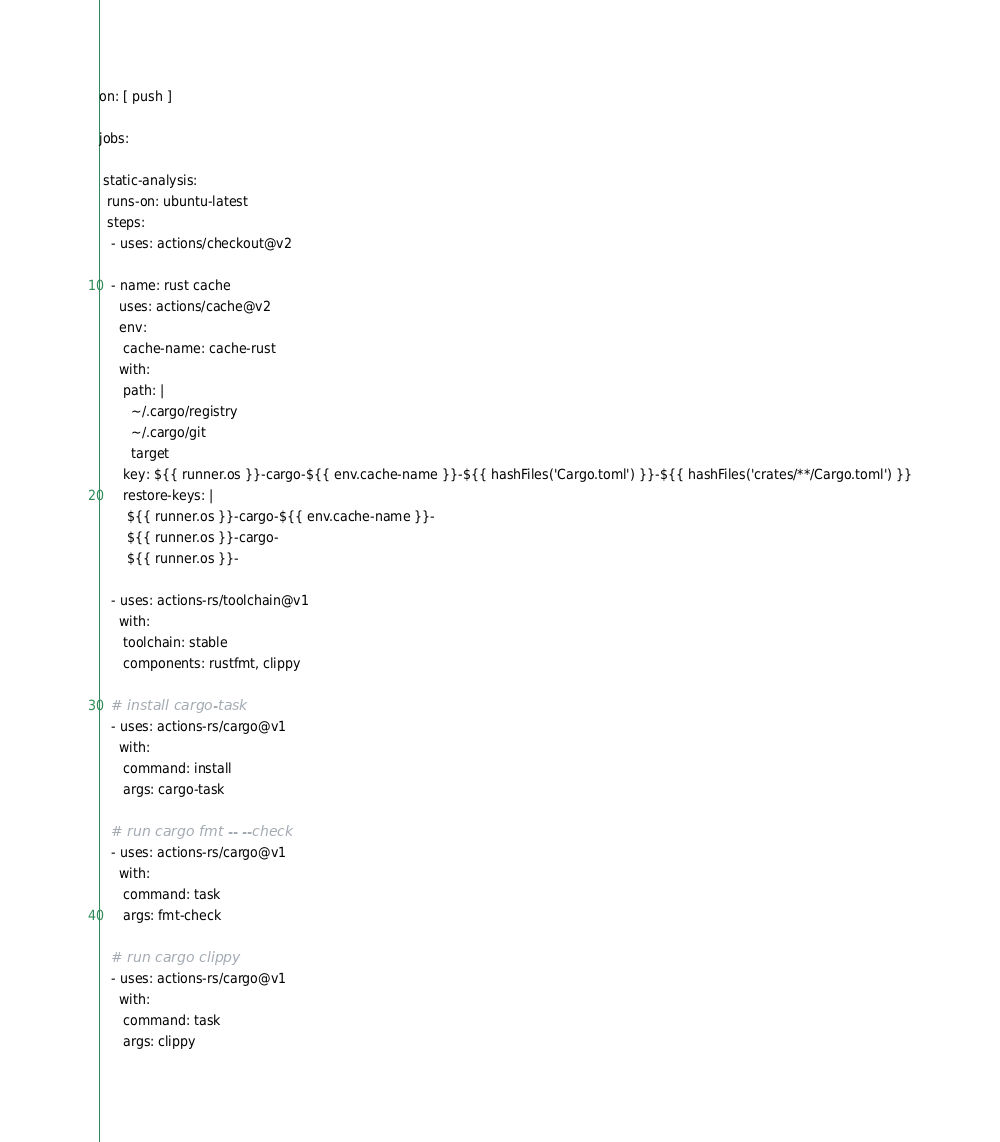<code> <loc_0><loc_0><loc_500><loc_500><_YAML_>on: [ push ]

jobs:

 static-analysis:
  runs-on: ubuntu-latest
  steps:
   - uses: actions/checkout@v2

   - name: rust cache
     uses: actions/cache@v2
     env:
      cache-name: cache-rust
     with:
      path: |
        ~/.cargo/registry
        ~/.cargo/git
        target
      key: ${{ runner.os }}-cargo-${{ env.cache-name }}-${{ hashFiles('Cargo.toml') }}-${{ hashFiles('crates/**/Cargo.toml') }}
      restore-keys: |
       ${{ runner.os }}-cargo-${{ env.cache-name }}-
       ${{ runner.os }}-cargo-
       ${{ runner.os }}-

   - uses: actions-rs/toolchain@v1
     with:
      toolchain: stable
      components: rustfmt, clippy

   # install cargo-task
   - uses: actions-rs/cargo@v1
     with:
      command: install
      args: cargo-task

   # run cargo fmt -- --check
   - uses: actions-rs/cargo@v1
     with:
      command: task
      args: fmt-check

   # run cargo clippy
   - uses: actions-rs/cargo@v1
     with:
      command: task
      args: clippy
</code> 